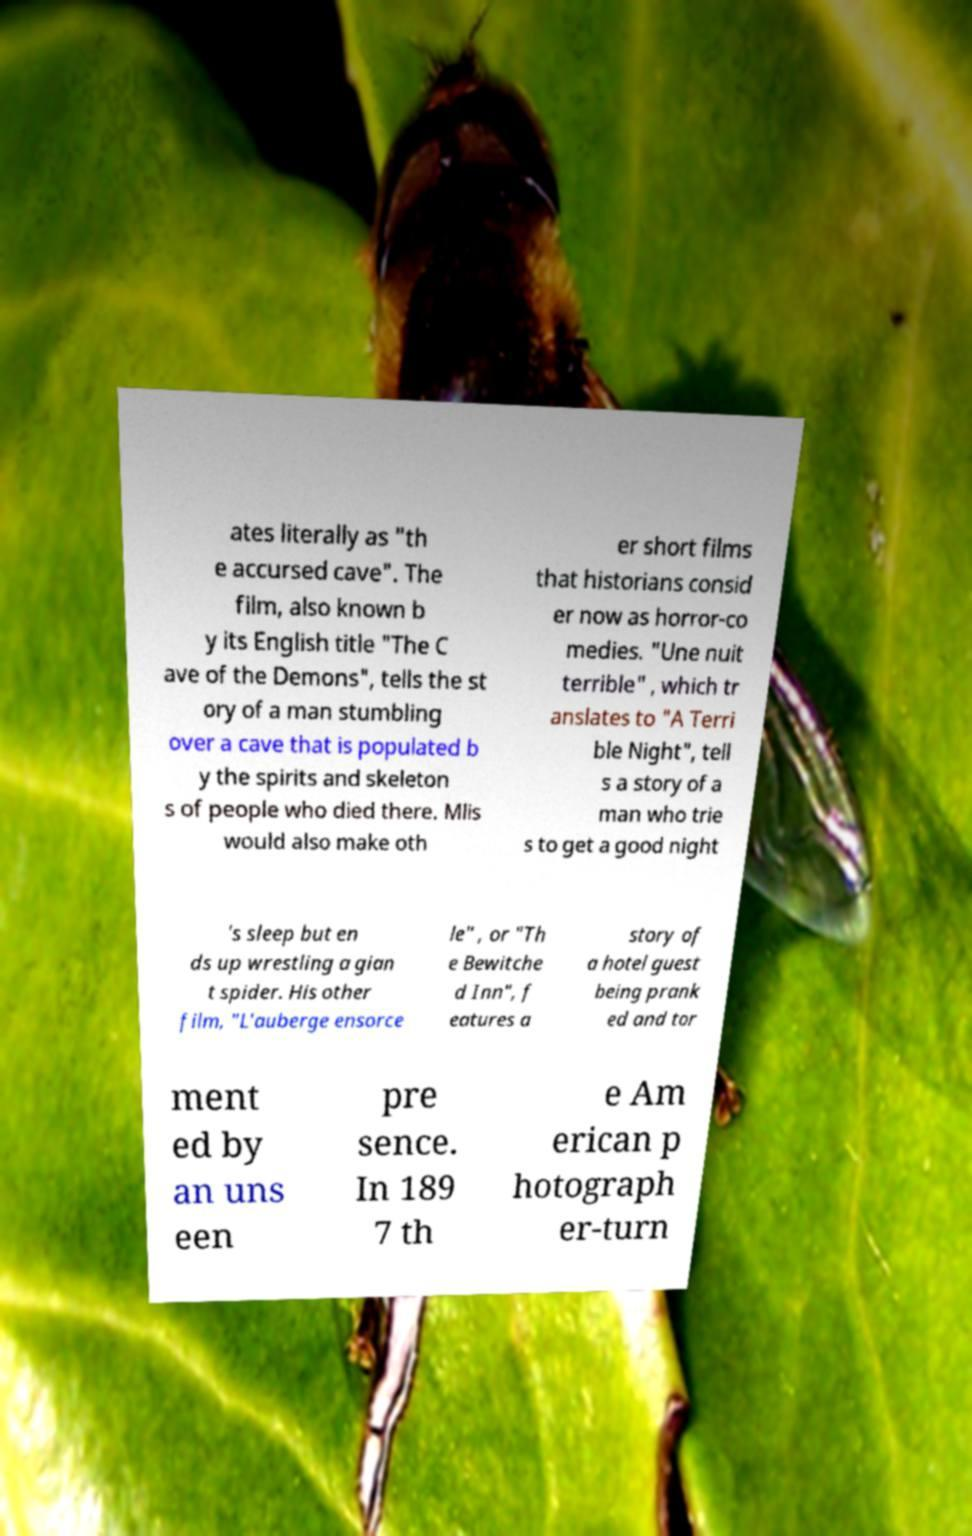For documentation purposes, I need the text within this image transcribed. Could you provide that? ates literally as "th e accursed cave". The film, also known b y its English title "The C ave of the Demons", tells the st ory of a man stumbling over a cave that is populated b y the spirits and skeleton s of people who died there. Mlis would also make oth er short films that historians consid er now as horror-co medies. "Une nuit terrible" , which tr anslates to "A Terri ble Night", tell s a story of a man who trie s to get a good night 's sleep but en ds up wrestling a gian t spider. His other film, "L'auberge ensorce le" , or "Th e Bewitche d Inn", f eatures a story of a hotel guest being prank ed and tor ment ed by an uns een pre sence. In 189 7 th e Am erican p hotograph er-turn 